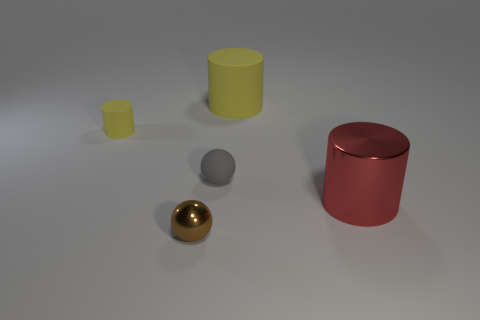Is there another tiny metal sphere that has the same color as the shiny ball? no 